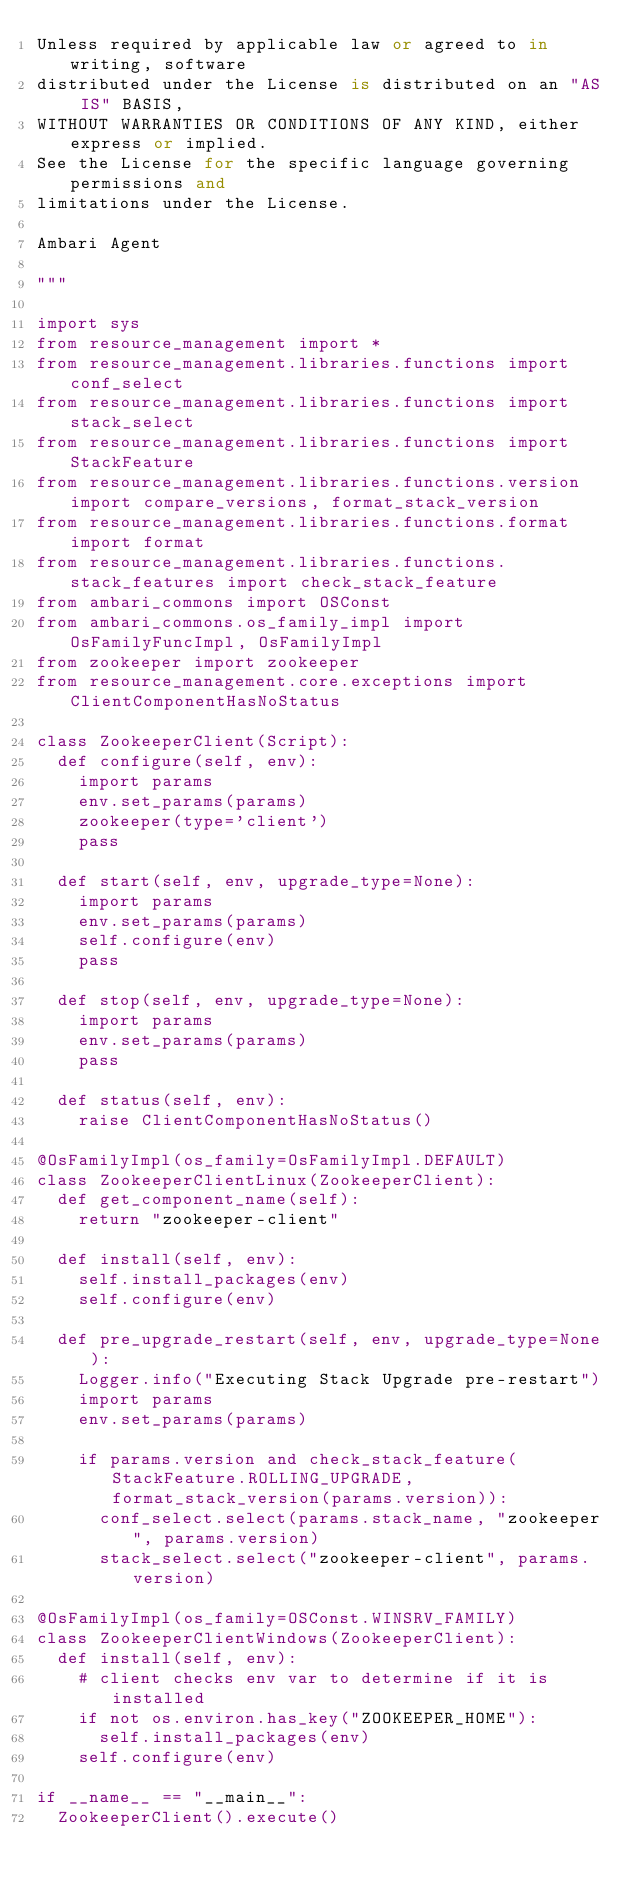<code> <loc_0><loc_0><loc_500><loc_500><_Python_>Unless required by applicable law or agreed to in writing, software
distributed under the License is distributed on an "AS IS" BASIS,
WITHOUT WARRANTIES OR CONDITIONS OF ANY KIND, either express or implied.
See the License for the specific language governing permissions and
limitations under the License.

Ambari Agent

"""

import sys
from resource_management import *
from resource_management.libraries.functions import conf_select
from resource_management.libraries.functions import stack_select
from resource_management.libraries.functions import StackFeature
from resource_management.libraries.functions.version import compare_versions, format_stack_version
from resource_management.libraries.functions.format import format
from resource_management.libraries.functions.stack_features import check_stack_feature 
from ambari_commons import OSConst
from ambari_commons.os_family_impl import OsFamilyFuncImpl, OsFamilyImpl
from zookeeper import zookeeper
from resource_management.core.exceptions import ClientComponentHasNoStatus

class ZookeeperClient(Script):
  def configure(self, env):
    import params
    env.set_params(params)
    zookeeper(type='client')
    pass

  def start(self, env, upgrade_type=None):
    import params
    env.set_params(params)
    self.configure(env)
    pass

  def stop(self, env, upgrade_type=None):
    import params
    env.set_params(params)
    pass

  def status(self, env):
    raise ClientComponentHasNoStatus()

@OsFamilyImpl(os_family=OsFamilyImpl.DEFAULT)
class ZookeeperClientLinux(ZookeeperClient):
  def get_component_name(self):
    return "zookeeper-client"

  def install(self, env):
    self.install_packages(env)
    self.configure(env)

  def pre_upgrade_restart(self, env, upgrade_type=None):
    Logger.info("Executing Stack Upgrade pre-restart")
    import params
    env.set_params(params)

    if params.version and check_stack_feature(StackFeature.ROLLING_UPGRADE, format_stack_version(params.version)):
      conf_select.select(params.stack_name, "zookeeper", params.version)
      stack_select.select("zookeeper-client", params.version)

@OsFamilyImpl(os_family=OSConst.WINSRV_FAMILY)
class ZookeeperClientWindows(ZookeeperClient):
  def install(self, env):
    # client checks env var to determine if it is installed
    if not os.environ.has_key("ZOOKEEPER_HOME"):
      self.install_packages(env)
    self.configure(env)

if __name__ == "__main__":
  ZookeeperClient().execute()
</code> 